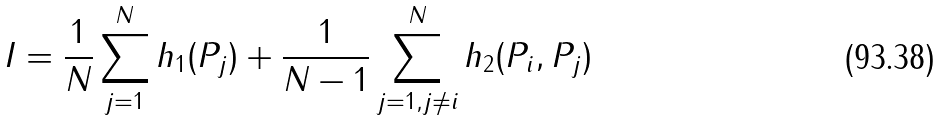<formula> <loc_0><loc_0><loc_500><loc_500>I = \frac { 1 } { N } \sum _ { j = 1 } ^ { N } h _ { 1 } ( P _ { j } ) + \frac { 1 } { N - 1 } \sum _ { j = 1 , j \neq i } ^ { N } h _ { 2 } ( P _ { i } , P _ { j } )</formula> 